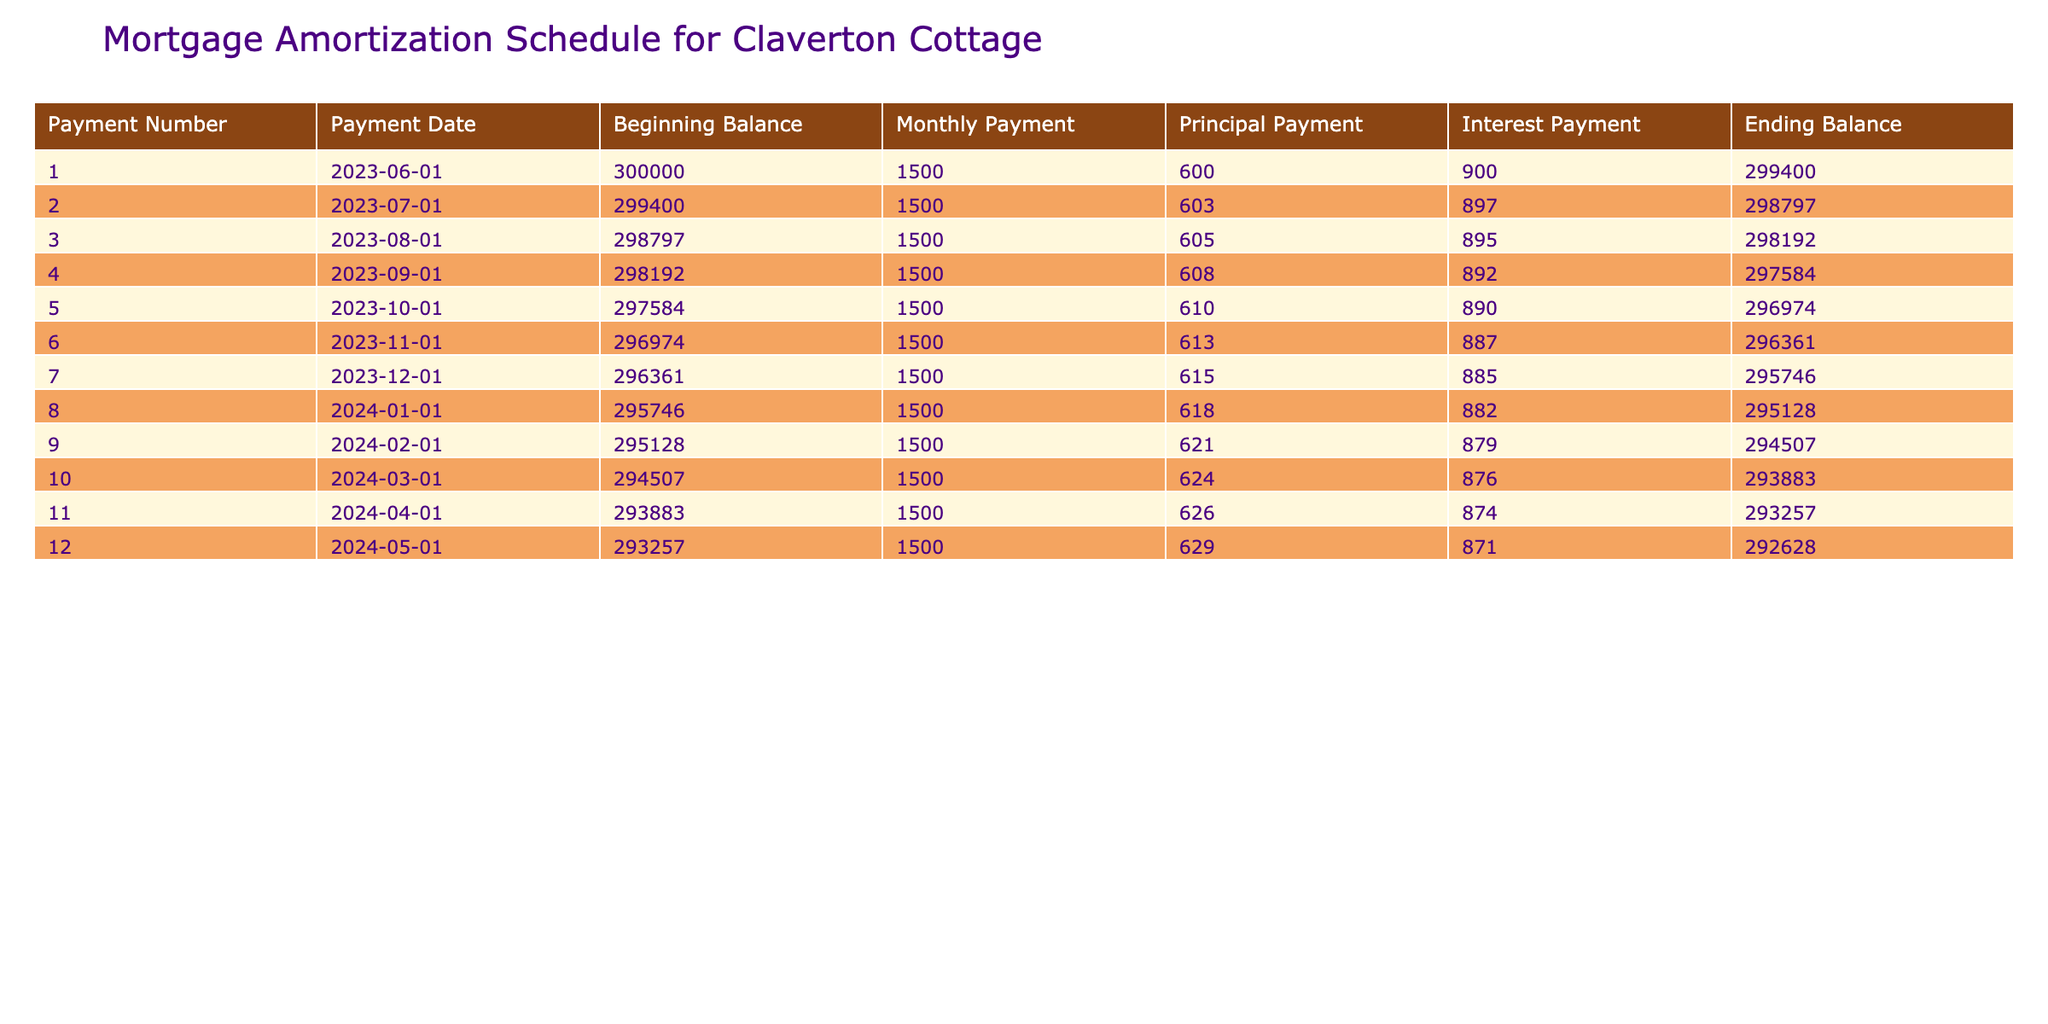What is the monthly payment for the mortgage? The monthly payment is listed in the table under the "Monthly Payment" column. It remains constant at £1500 throughout each payment period, as shown by each row in the table.
Answer: £1500 How much principal is paid off in the first payment? To find the principal payment for the first payment, refer to the "Principal Payment" column in the first row, which indicates that £600 was paid towards the principal in that payment period.
Answer: £600 What is the total principal paid after the first three payments? To calculate the total principal paid after the first three payments, we add the principal payments from the first three rows: £600 (first) + £603 (second) + £605 (third) = £1808.
Answer: £1808 Did the interest payment decrease in the second month compared to the first month? By comparing the interest payment amounts in the table's "Interest Payment" column for the first month (£900) and the second month (£897), we see that the second payment is lower than the first.
Answer: Yes What is the ending balance after the sixth payment? The ending balance after the sixth payment is listed in the "Ending Balance" column for the sixth row, which shows £296361 as the remaining principal balance.
Answer: £296361 What is the difference in total interest paid between the first two payments? The interest payments for the first two payments are £900 and £897, respectively. The difference is calculated as £900 (first payment interest) - £897 (second payment interest) = £3.
Answer: £3 What is the average principal payment for the first twelve payments? To find the average principal payment, we need to first sum the principal payments from all twelve payments and then divide by 12. The total principal paid is £600 + £603 + £605 + £608 + £610 + £613 + £615 + £618 + £621 + £624 + £626 + £629 = £7,433. Dividing this by 12 gives an average of £619.42 (approximately).
Answer: £619.42 How much is the total payment made by the end of the first year? To calculate the total payments made by the end of the first year (12 months), we take the monthly payment and multiply it by 12: £1500 (monthly payment) * 12 = £18,000.
Answer: £18,000 Is the ending balance after the tenth payment higher than the beginning balance after the ninth payment? Checking the "Ending Balance" after the tenth payment is £293883 and the "Beginning Balance" after the ninth payment is £295128. Since £293883 is less than £295128, the ending balance after the tenth payment is not higher.
Answer: No 